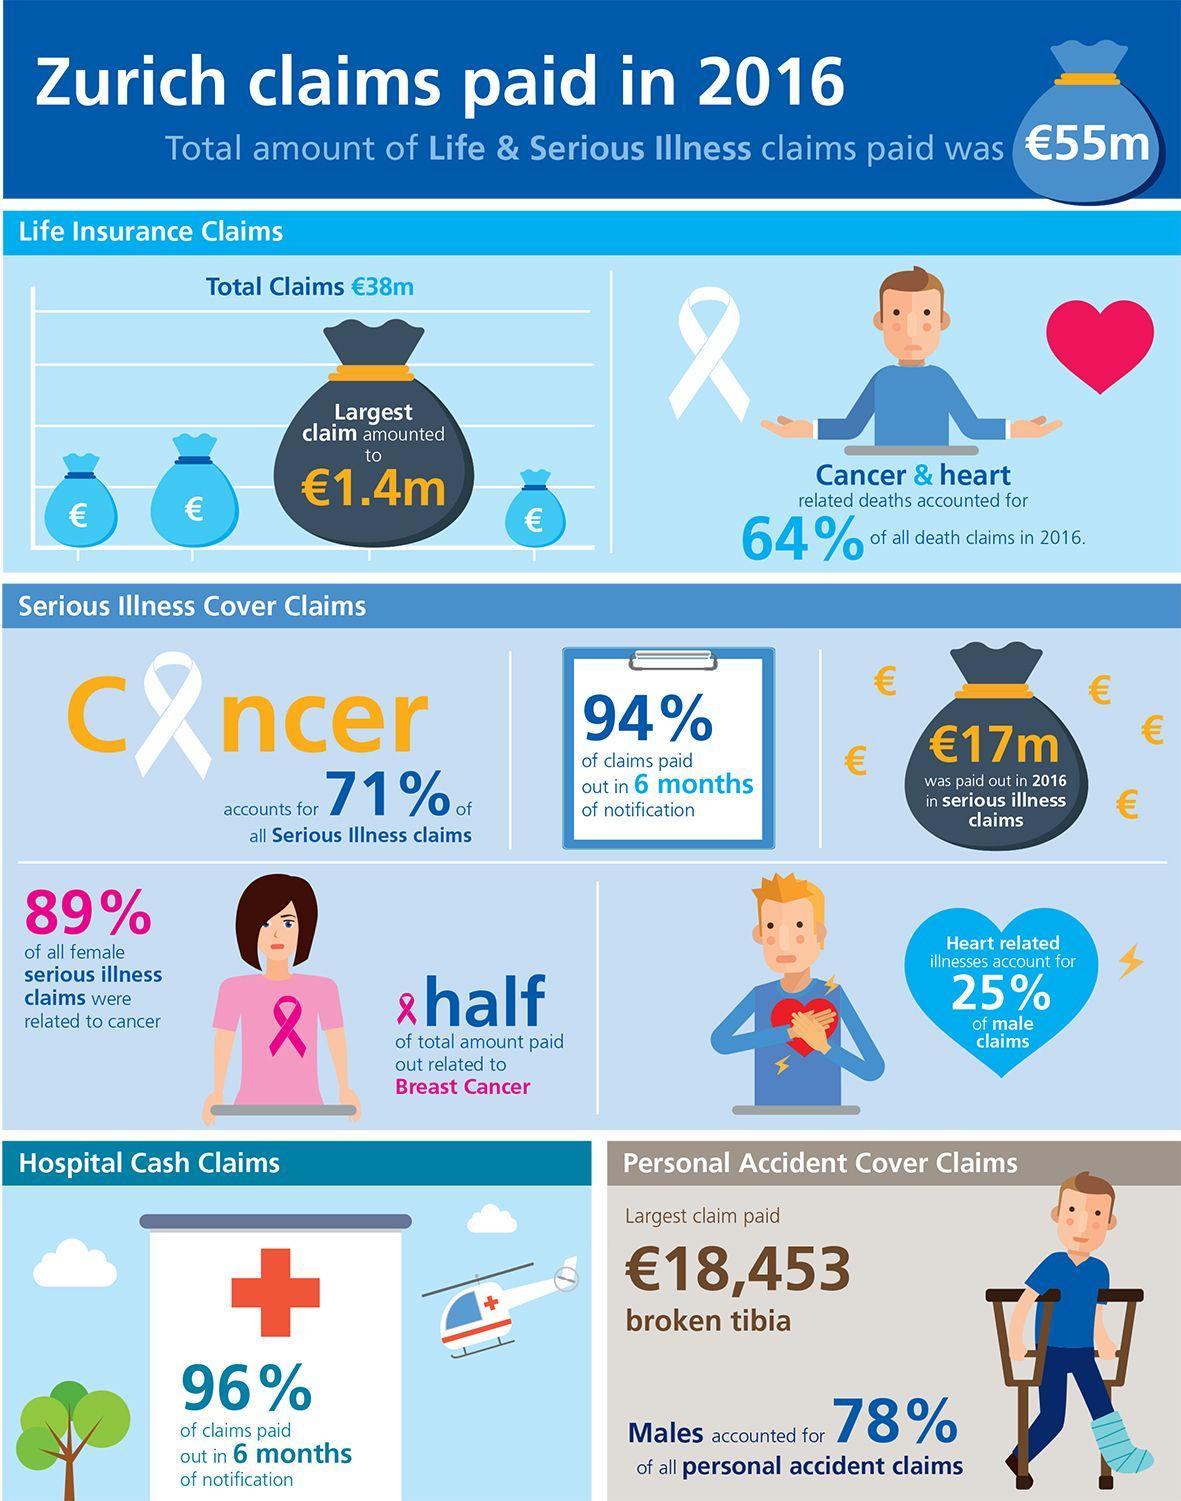Identify some key points in this picture. The largest claim paid in personal accident cover claims was for a broken tibia. Only 11% of all female serious illness claims were not related to cancer. 